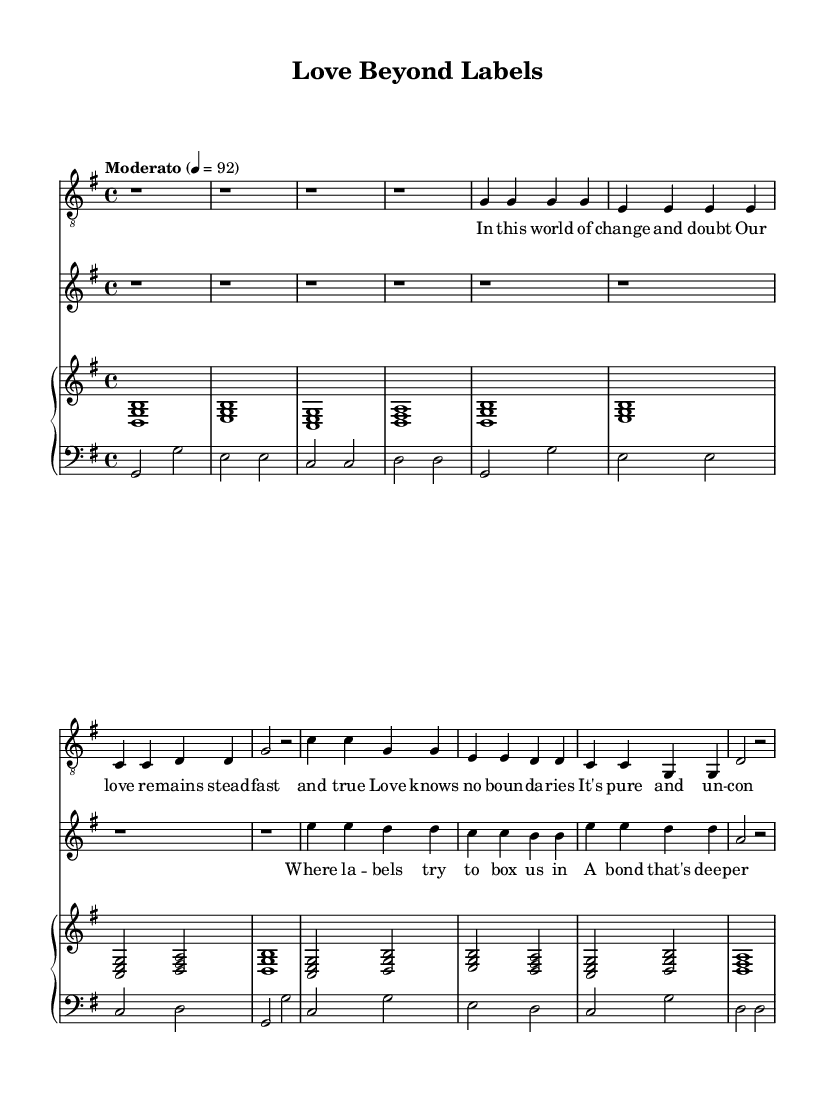What is the key signature of this music? The key signature shows one sharp (F#), indicating that this piece is in G major. This is visible at the beginning of the staff as there is a single sharp symbol placed on the F line.
Answer: G major What is the time signature of this music? The time signature is 4/4, which means there are four beats in each measure. This can be seen at the start of the music, denoted by the fraction "4/4".
Answer: 4/4 What is the tempo marking for this piece? The tempo marking indicates "Moderato," which suggests a moderate speed for the performance of the piece. This marking is found in the tempo indications near the beginning of the sheet music.
Answer: Moderato How many measures are in the father’s part before the daughter starts singing? The father’s part includes four measures of rests followed by measures where he starts singing, making a total of four measures before the daughter joins. The rests are all notated as 'r' at the start of the first staff for the father.
Answer: 4 Which lyric starts with "In this world of change"? This lyric is the first line of the father’s lyrics, clearly positioned underneath the notes in the father’s Vocal part. It is easy to identify by looking at the lyrics section aligned with the first phrase of notes.
Answer: In this world of change What is the main theme of the song based on the lyrics? The main theme is centered around love and connections that transcend societal labels. By examining both sets of lyrics, we see that both express a message of unconditional love and a bond that is deeper than appearances or societal constraints.
Answer: Unconditional love What instrument is used to accompany the duet? The accompaniment features a piano, which is indicated by the separate staff labeled as "PianoStaff" in the sheet music. The notation for the piano part appears below the vocal parts showcasing the accompaniment for both voices.
Answer: Piano 